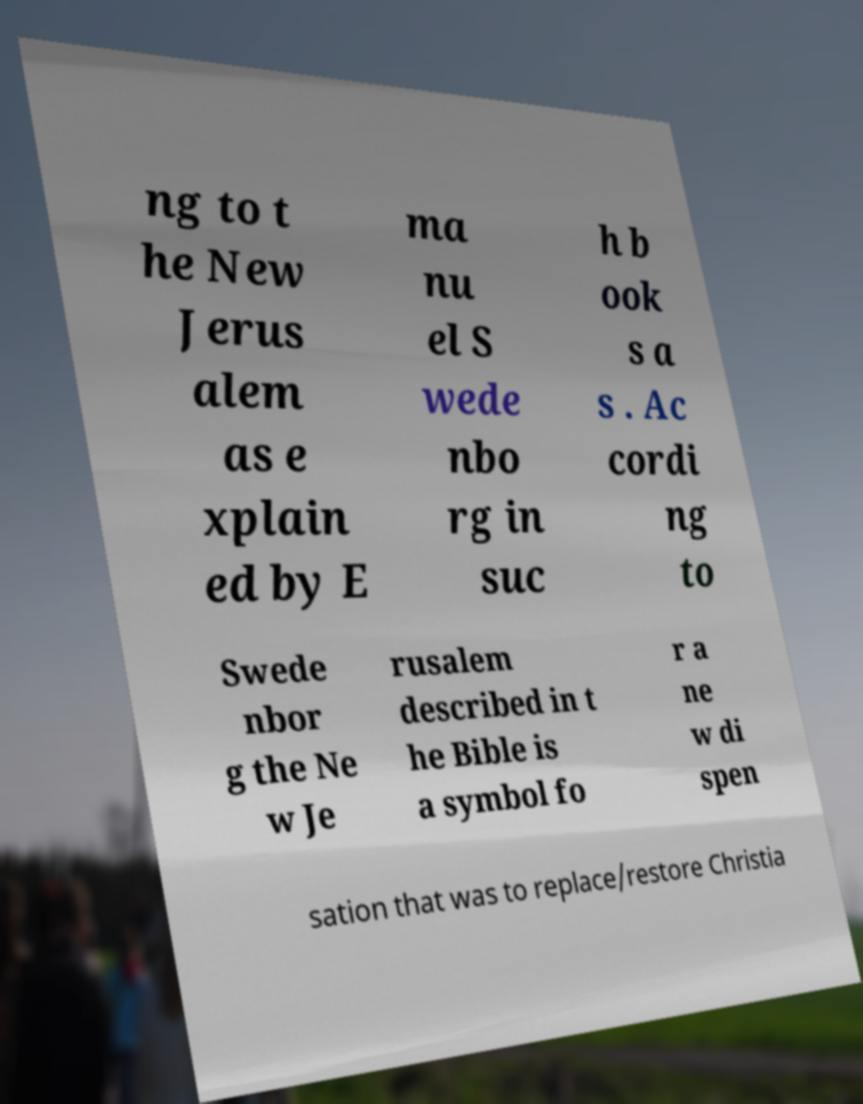Please read and relay the text visible in this image. What does it say? ng to t he New Jerus alem as e xplain ed by E ma nu el S wede nbo rg in suc h b ook s a s . Ac cordi ng to Swede nbor g the Ne w Je rusalem described in t he Bible is a symbol fo r a ne w di spen sation that was to replace/restore Christia 